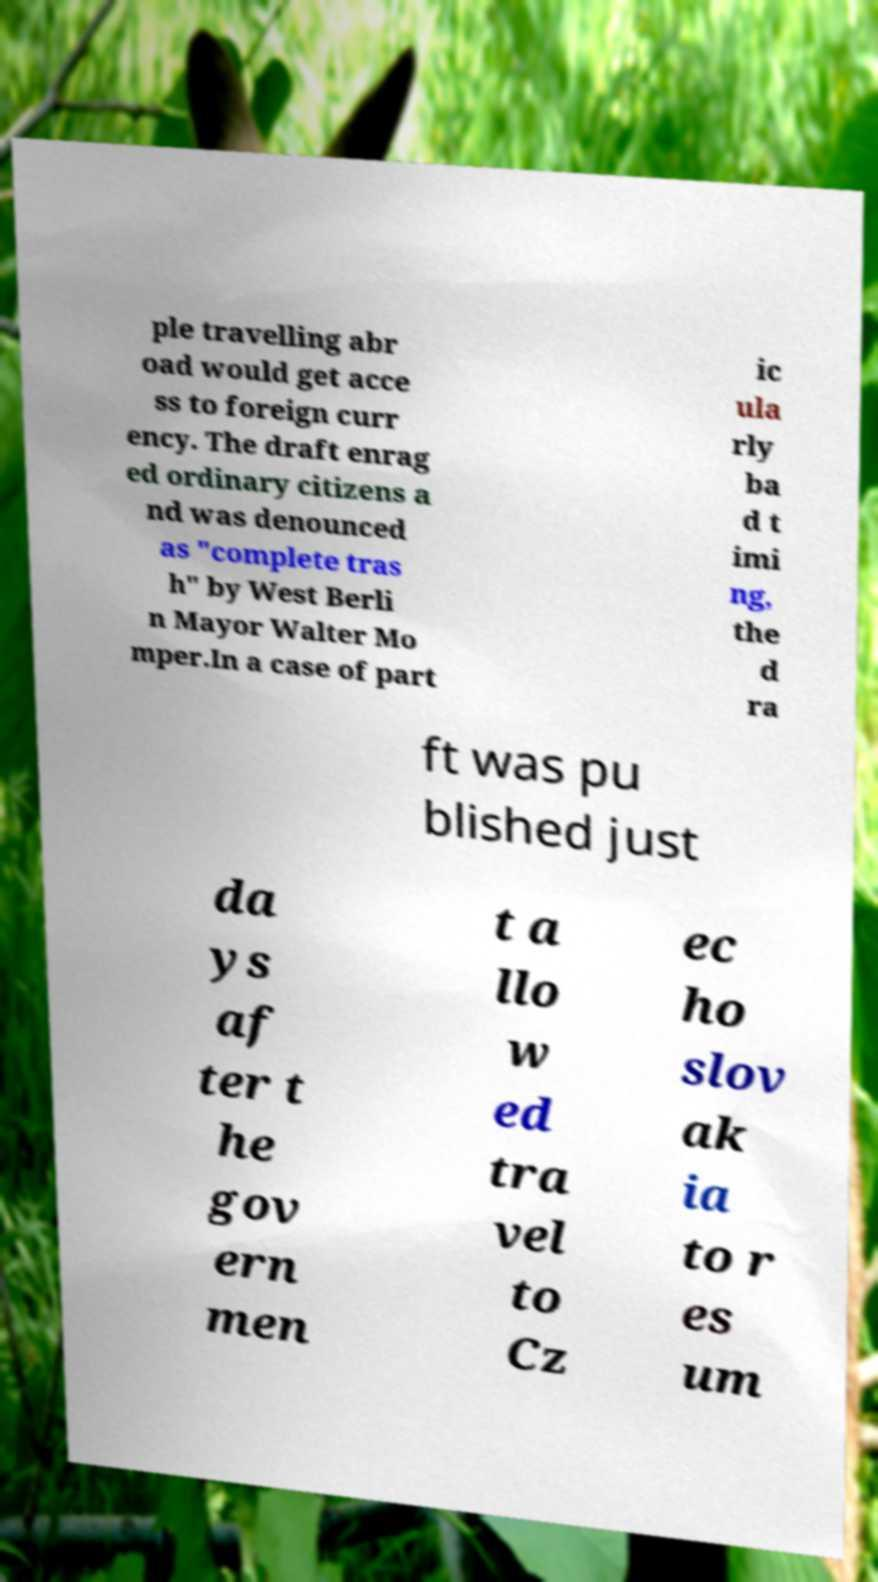For documentation purposes, I need the text within this image transcribed. Could you provide that? ple travelling abr oad would get acce ss to foreign curr ency. The draft enrag ed ordinary citizens a nd was denounced as "complete tras h" by West Berli n Mayor Walter Mo mper.In a case of part ic ula rly ba d t imi ng, the d ra ft was pu blished just da ys af ter t he gov ern men t a llo w ed tra vel to Cz ec ho slov ak ia to r es um 